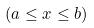Convert formula to latex. <formula><loc_0><loc_0><loc_500><loc_500>( a \leq x \leq b )</formula> 